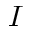Convert formula to latex. <formula><loc_0><loc_0><loc_500><loc_500>I</formula> 